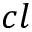Convert formula to latex. <formula><loc_0><loc_0><loc_500><loc_500>c l</formula> 